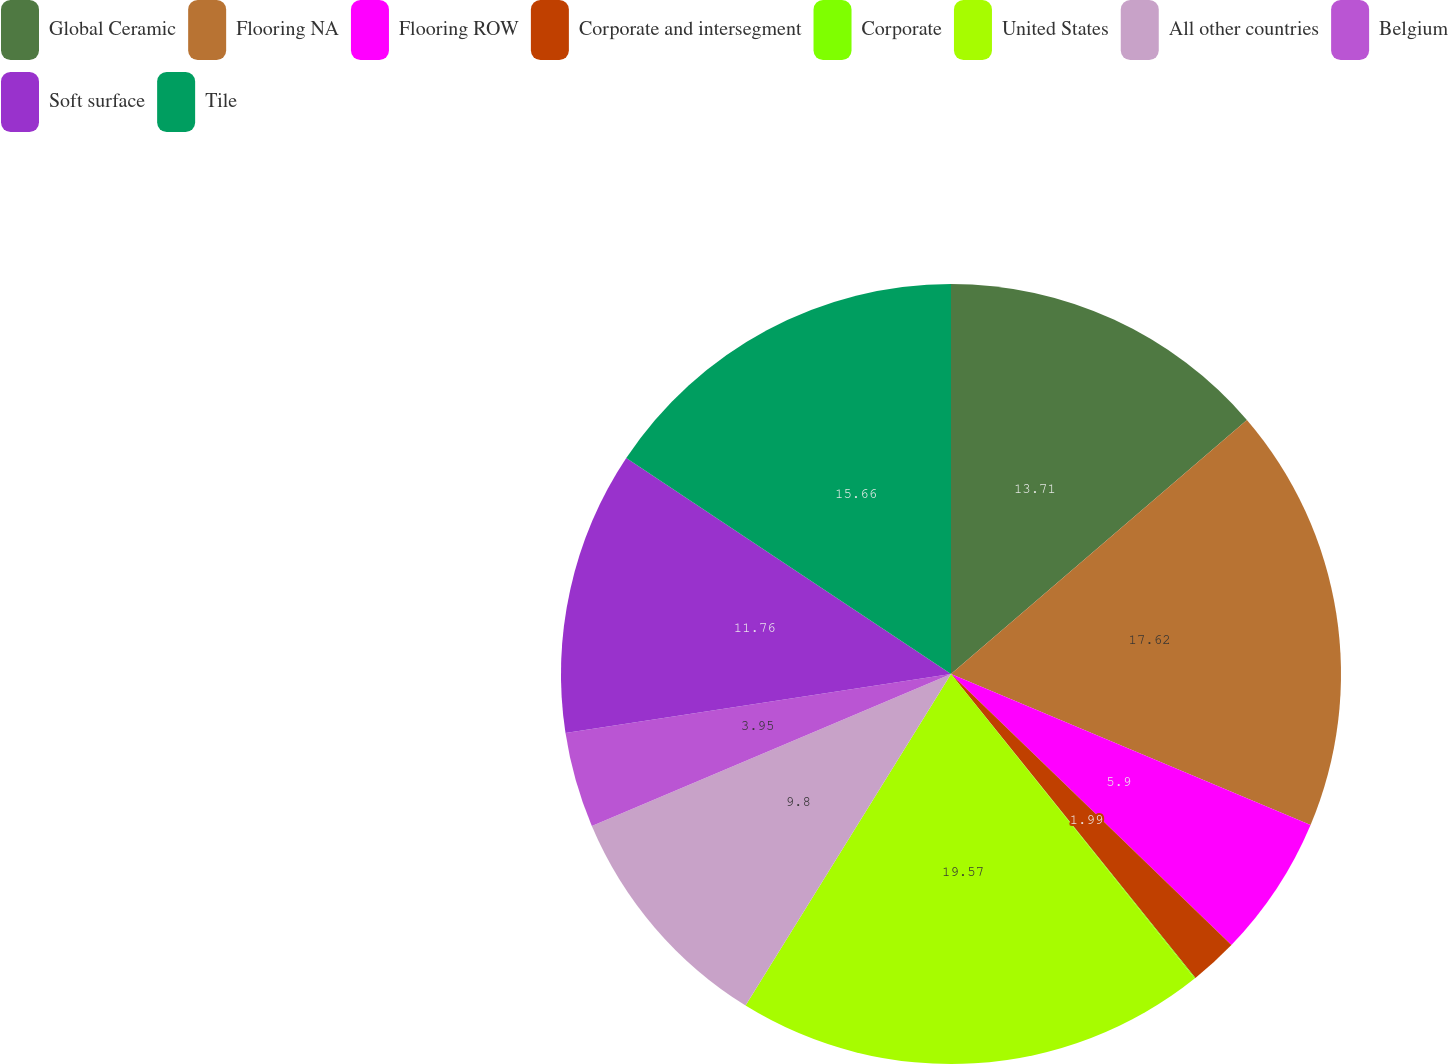Convert chart to OTSL. <chart><loc_0><loc_0><loc_500><loc_500><pie_chart><fcel>Global Ceramic<fcel>Flooring NA<fcel>Flooring ROW<fcel>Corporate and intersegment<fcel>Corporate<fcel>United States<fcel>All other countries<fcel>Belgium<fcel>Soft surface<fcel>Tile<nl><fcel>13.71%<fcel>17.62%<fcel>5.9%<fcel>1.99%<fcel>0.04%<fcel>19.57%<fcel>9.8%<fcel>3.95%<fcel>11.76%<fcel>15.66%<nl></chart> 